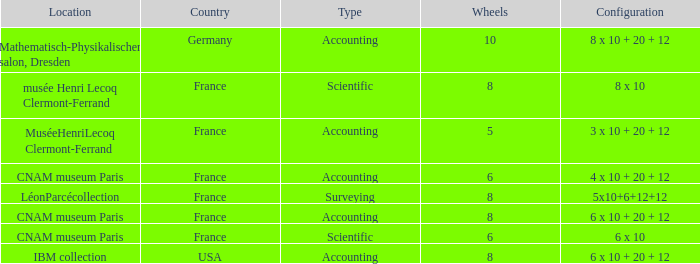What is the configuration for the country France, with accounting as the type, and wheels greater than 6? 6 x 10 + 20 + 12. 